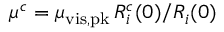Convert formula to latex. <formula><loc_0><loc_0><loc_500><loc_500>{ \, \mu ^ { c } } = { \mu _ { v i s , p k } } \, R _ { i } ^ { c } ( 0 ) / R _ { i } ( 0 )</formula> 